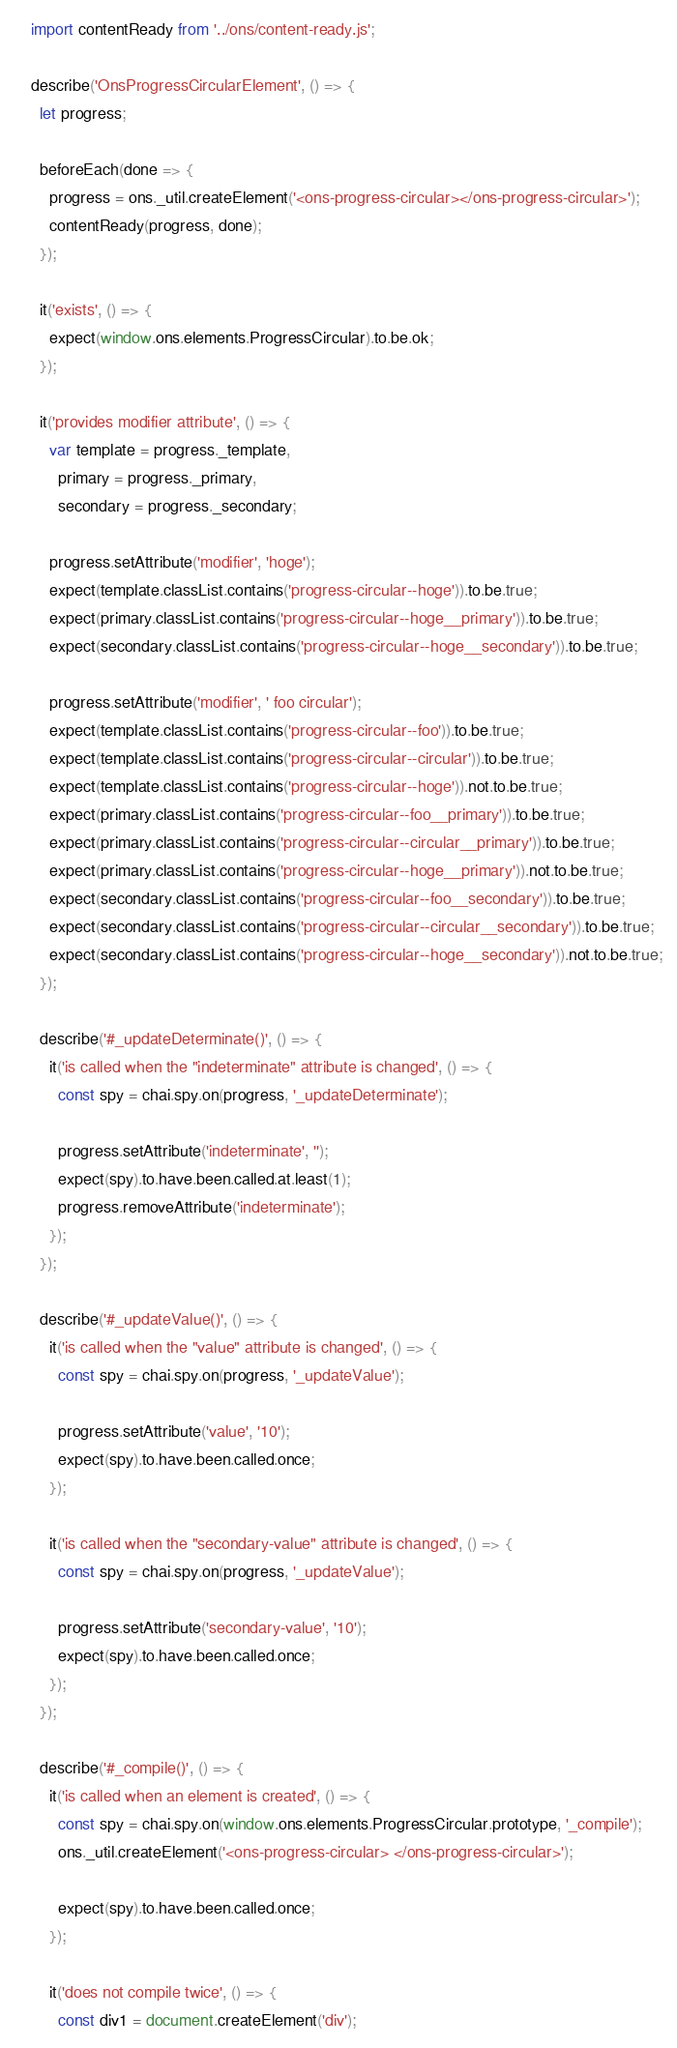Convert code to text. <code><loc_0><loc_0><loc_500><loc_500><_JavaScript_>import contentReady from '../ons/content-ready.js';

describe('OnsProgressCircularElement', () => {
  let progress;

  beforeEach(done => {
    progress = ons._util.createElement('<ons-progress-circular></ons-progress-circular>');
    contentReady(progress, done);
  });

  it('exists', () => {
    expect(window.ons.elements.ProgressCircular).to.be.ok;
  });

  it('provides modifier attribute', () => {
    var template = progress._template,
      primary = progress._primary,
      secondary = progress._secondary;

    progress.setAttribute('modifier', 'hoge');
    expect(template.classList.contains('progress-circular--hoge')).to.be.true;
    expect(primary.classList.contains('progress-circular--hoge__primary')).to.be.true;
    expect(secondary.classList.contains('progress-circular--hoge__secondary')).to.be.true;

    progress.setAttribute('modifier', ' foo circular');
    expect(template.classList.contains('progress-circular--foo')).to.be.true;
    expect(template.classList.contains('progress-circular--circular')).to.be.true;
    expect(template.classList.contains('progress-circular--hoge')).not.to.be.true;
    expect(primary.classList.contains('progress-circular--foo__primary')).to.be.true;
    expect(primary.classList.contains('progress-circular--circular__primary')).to.be.true;
    expect(primary.classList.contains('progress-circular--hoge__primary')).not.to.be.true;
    expect(secondary.classList.contains('progress-circular--foo__secondary')).to.be.true;
    expect(secondary.classList.contains('progress-circular--circular__secondary')).to.be.true;
    expect(secondary.classList.contains('progress-circular--hoge__secondary')).not.to.be.true;
  });

  describe('#_updateDeterminate()', () => {
    it('is called when the "indeterminate" attribute is changed', () => {
      const spy = chai.spy.on(progress, '_updateDeterminate');

      progress.setAttribute('indeterminate', '');
      expect(spy).to.have.been.called.at.least(1);
      progress.removeAttribute('indeterminate');
    });
  });

  describe('#_updateValue()', () => {
    it('is called when the "value" attribute is changed', () => {
      const spy = chai.spy.on(progress, '_updateValue');

      progress.setAttribute('value', '10');
      expect(spy).to.have.been.called.once;
    });

    it('is called when the "secondary-value" attribute is changed', () => {
      const spy = chai.spy.on(progress, '_updateValue');

      progress.setAttribute('secondary-value', '10');
      expect(spy).to.have.been.called.once;
    });
  });

  describe('#_compile()', () => {
    it('is called when an element is created', () => {
      const spy = chai.spy.on(window.ons.elements.ProgressCircular.prototype, '_compile');
      ons._util.createElement('<ons-progress-circular> </ons-progress-circular>');

      expect(spy).to.have.been.called.once;
    });

    it('does not compile twice', () => {
      const div1 = document.createElement('div');</code> 